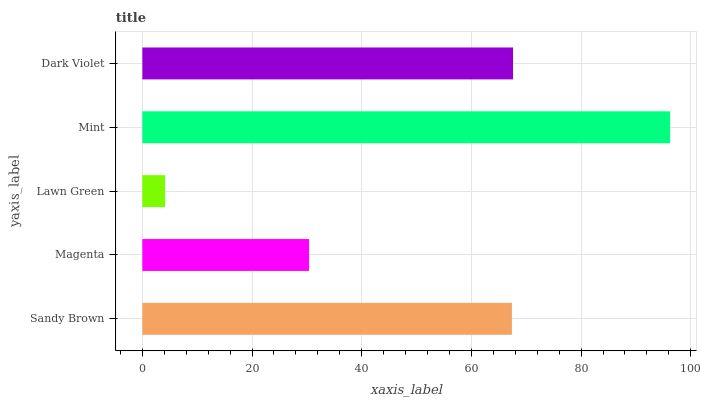Is Lawn Green the minimum?
Answer yes or no. Yes. Is Mint the maximum?
Answer yes or no. Yes. Is Magenta the minimum?
Answer yes or no. No. Is Magenta the maximum?
Answer yes or no. No. Is Sandy Brown greater than Magenta?
Answer yes or no. Yes. Is Magenta less than Sandy Brown?
Answer yes or no. Yes. Is Magenta greater than Sandy Brown?
Answer yes or no. No. Is Sandy Brown less than Magenta?
Answer yes or no. No. Is Sandy Brown the high median?
Answer yes or no. Yes. Is Sandy Brown the low median?
Answer yes or no. Yes. Is Dark Violet the high median?
Answer yes or no. No. Is Lawn Green the low median?
Answer yes or no. No. 